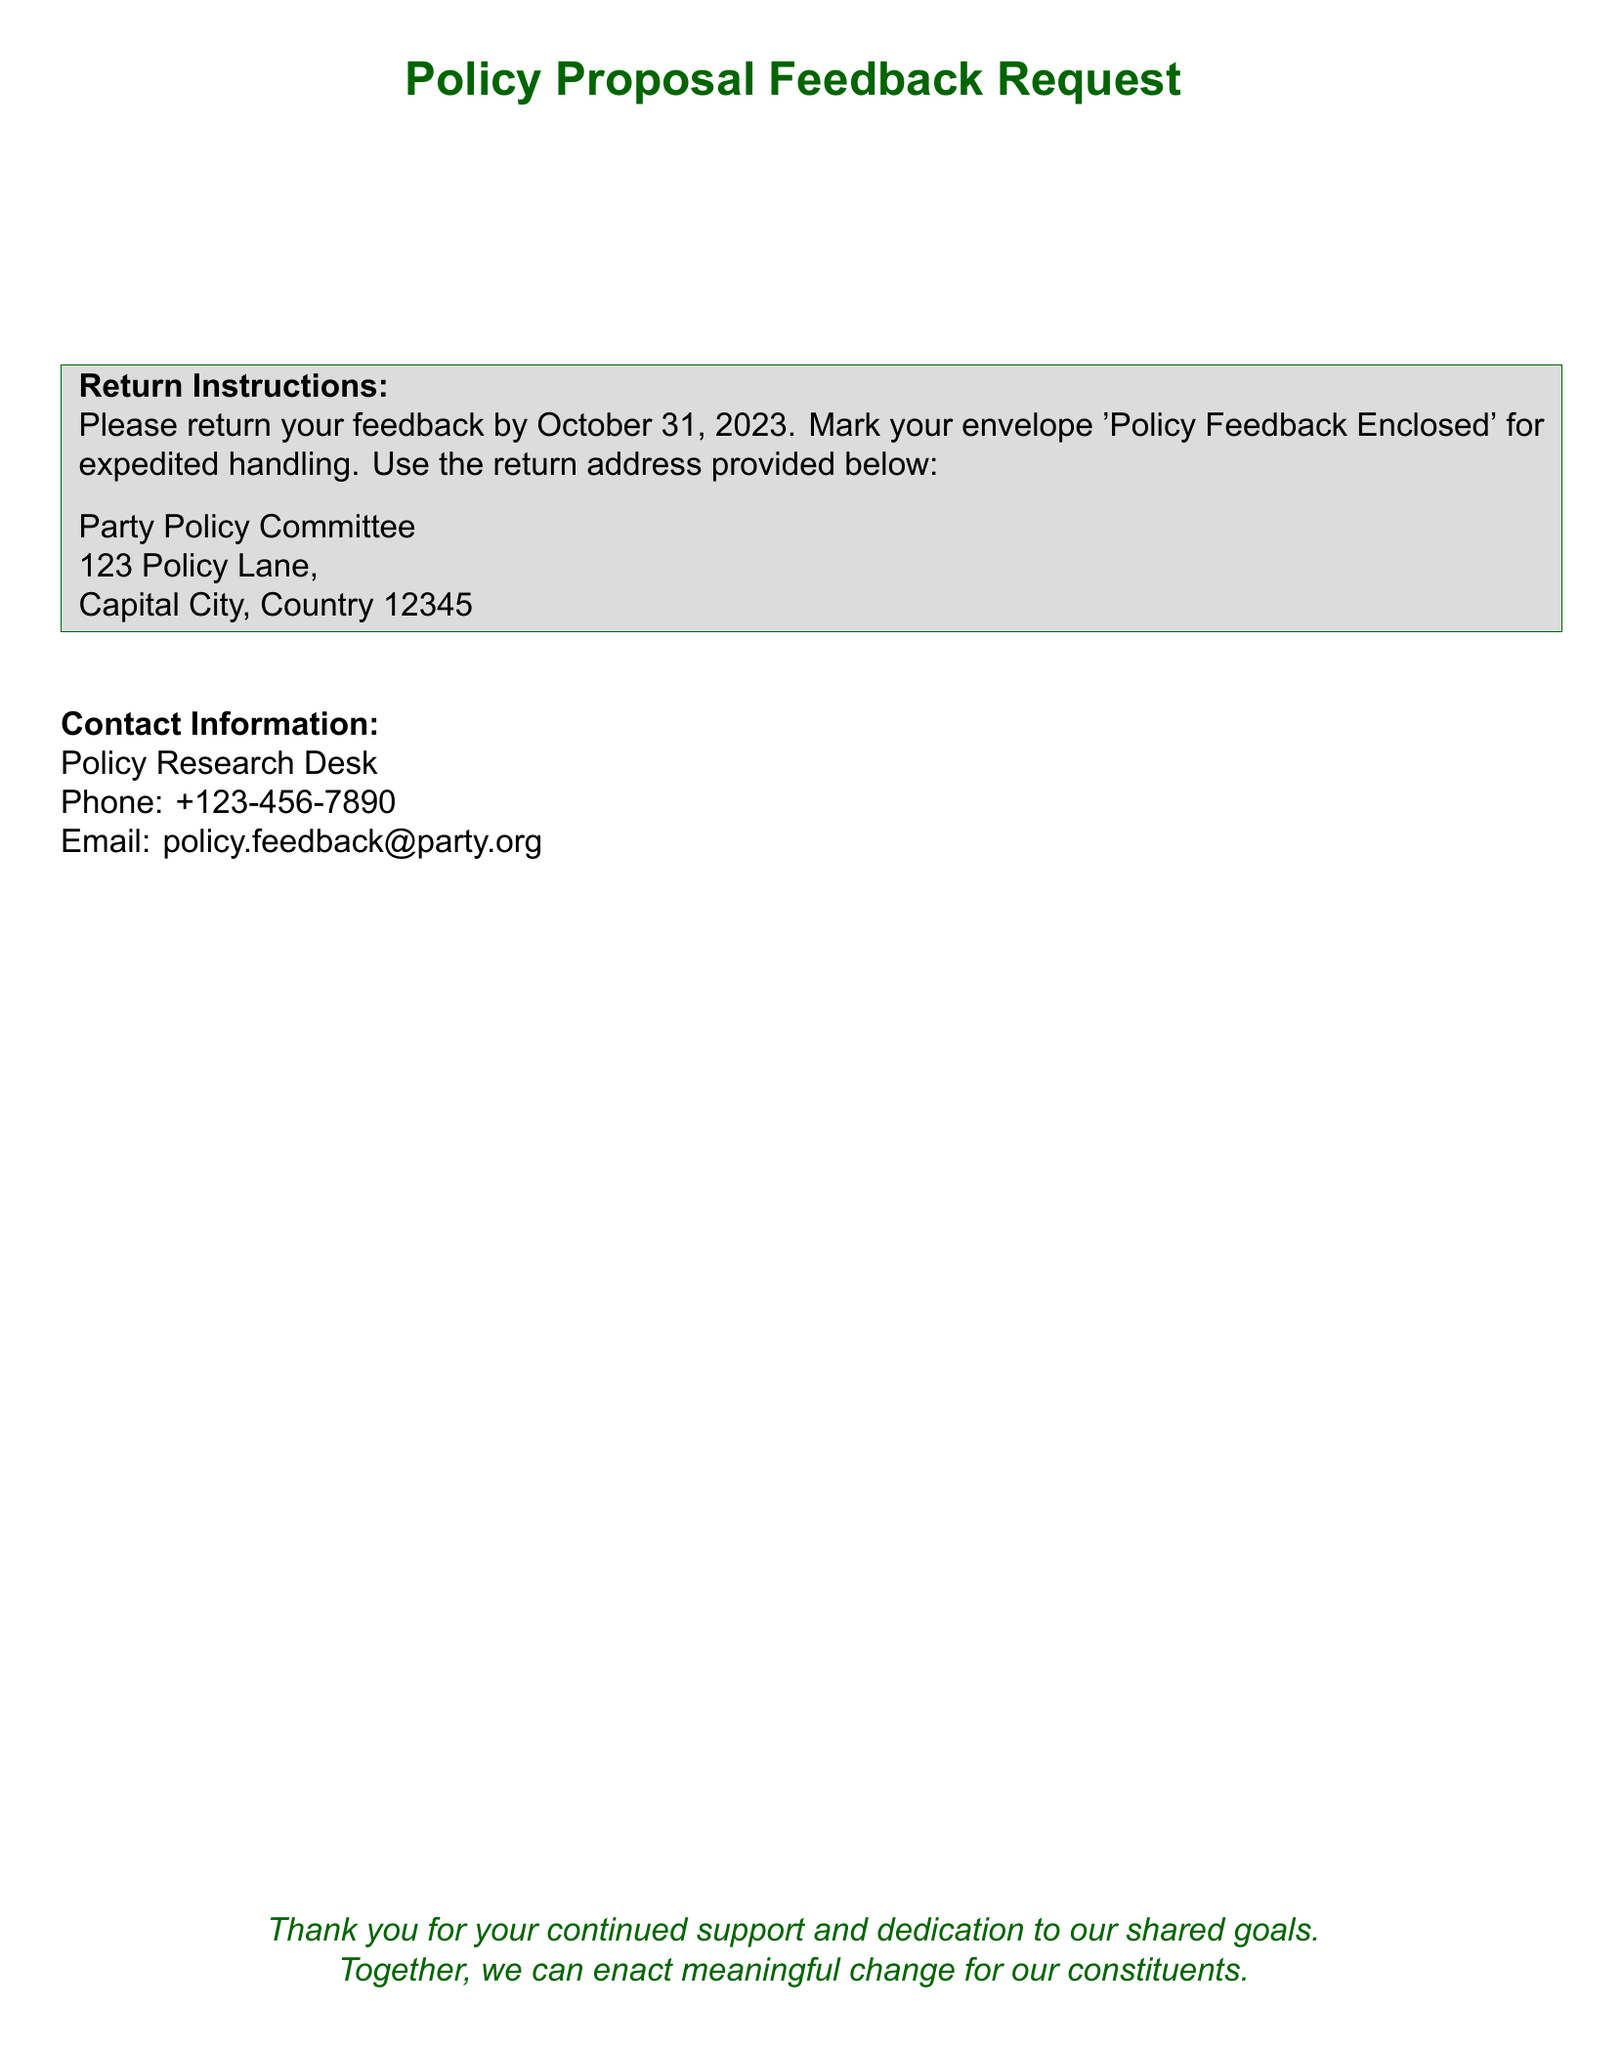What is the deadline for feedback submission? The document specifies that feedback should be returned by October 31, 2023.
Answer: October 31, 2023 Who is the sender of the document? The document identifies the sender as the Party Policy Committee.
Answer: Party Policy Committee What should be marked on the envelope? The document specifies to mark the envelope as 'Policy Feedback Enclosed' for expedited handling.
Answer: Policy Feedback Enclosed What is the contact phone number provided? The contact information in the document lists the phone number as +123-456-7890.
Answer: +123-456-7890 What is the return address? The document provides the return address as 123 Policy Lane, Capital City, Country 12345.
Answer: 123 Policy Lane, Capital City, Country 12345 To whom is the document addressed? The document is addressed to Lawmakers & Policy Advisers.
Answer: Lawmakers & Policy Advisers What color scheme is used in the document? The document prominently features a main color defined as dark green.
Answer: Dark green What type of document is this? This document is classified as a Policy Proposal Feedback Request.
Answer: Policy Proposal Feedback Request 